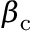<formula> <loc_0><loc_0><loc_500><loc_500>\beta _ { \mathrm c }</formula> 